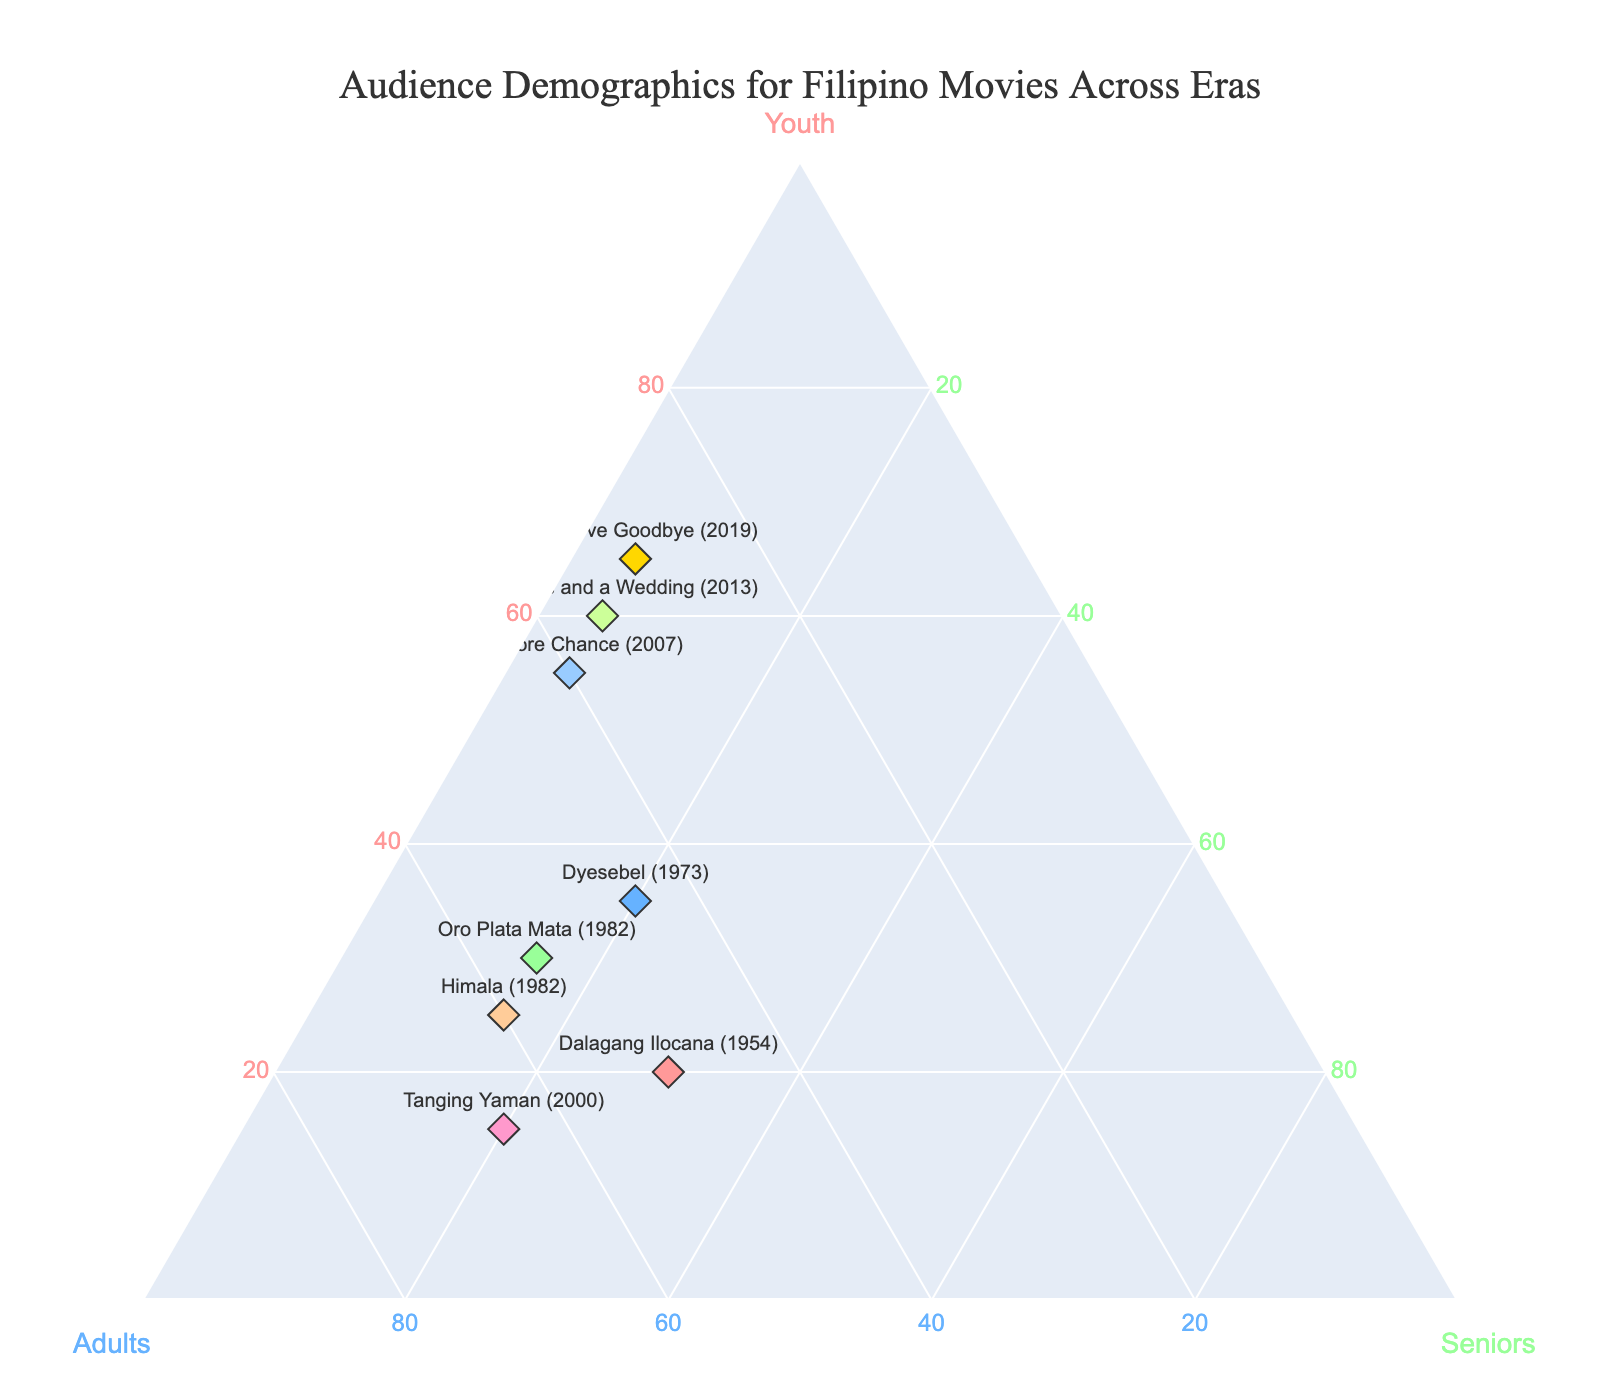Which movie has the highest percentage of youth in its audience? Look at the points representing the movies in the ternary plot and identify the one closest to the 'Youth' axis. "Hello Love Goodbye" (2019) is positioned closest to this axis with 65% youth in its audience.
Answer: "Hello Love Goodbye" (2019) Which movie has the highest percentage of adults in its audience? Look at the points representing the movies in the ternary plot and identify the one closest to the 'Adults' axis. "Tanging Yaman" (2000) has 65% adults in its audience, placing it closest to the 'Adults' axis.
Answer: "Tanging Yaman" (2000) Which movies have the lowest percentage of seniors in their audience? Look at the points representing the movies in the ternary plot and identify those closest to the "Youth" and "Adults" axes since "Seniors" would be low. Both "One More Chance" (2007), "Four Sisters and a Wedding" (2013), and "Hello Love Goodbye" (2019) have only 5% seniors in their audience.
Answer: "One More Chance" (2007), "Four Sisters and a Wedding" (2013), "Hello Love Goodbye" (2019) How does the audience composition of "Oro Plata Mata" (1982) compare to "Dyesebel" (1973)? Observe the positions and values of the points for both movies on the ternary plot. "Oro Plata Mata" (1982) has 30% youth, 55% adults, and 15% seniors while "Dyesebel" (1973) has 35% youth, 45% adults, and 20% seniors. To compare, "Dyesebel" has 5% more youth, 10% fewer adults, and 5% more seniors.
Answer: "Dyesebel" (1973) has more youth and seniors, fewer adults What's the average percentage of adults among all movies? Sum up the percentages of adults for all movies and divide by the total number of movies. (50+45+55+60+65+40+35+30)/8 = 380/8.
Answer: 47.5% Which era has the most balanced audience demographic across youth, adults, and seniors? Look for the point closest to the center of the ternary plot indicating a balanced distribution. "Dalagang Ilocana" (1954) has 20% youth, 50% adults, and 30% seniors, which is the most balanced among the movies shown.
Answer: "Dalagang Ilocana" (1954) Are there any movies where the percentage of youth exceeds that of adults? Compare the 'Youth' and 'Adults' values for all points in the ternary plot. "One More Chance" (2007), "Four Sisters and a Wedding" (2013), and "Hello Love Goodbye" (2019) all have higher youth percentages compared to adults.
Answer: Yes, three movies What’s the total percentage of seniors across all movies? Sum up the percentages of seniors for all movies. 30+20+15+15+20+5+5+5 = 115.
Answer: 115% Which movie from the 1980s has the highest percentage of adults? Identify the movies from the 1980s and compare their 'Adults' values. Between "Oro Plata Mata" (1982) with 55% and "Himala" (1982) with 60%, "Himala" has the highest percentage of adults.
Answer: "Himala" (1982) What trend can you observe about the youth percentage in more recent movies compared to older ones? Compare the positions of older movies to the more recent ones regarding the 'Youth' axis. It is noticeable that recent movies like "One More Chance" (2007), "Four Sisters and a Wedding" (2013), and "Hello Love Goodbye" (2019) have a higher percentage of youth.
Answer: Increasing trend in youth percentage 